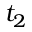<formula> <loc_0><loc_0><loc_500><loc_500>t _ { 2 }</formula> 